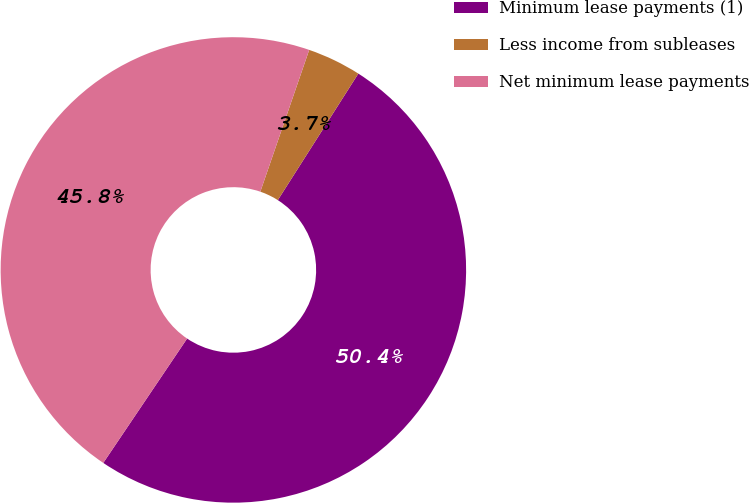Convert chart. <chart><loc_0><loc_0><loc_500><loc_500><pie_chart><fcel>Minimum lease payments (1)<fcel>Less income from subleases<fcel>Net minimum lease payments<nl><fcel>50.42%<fcel>3.74%<fcel>45.84%<nl></chart> 